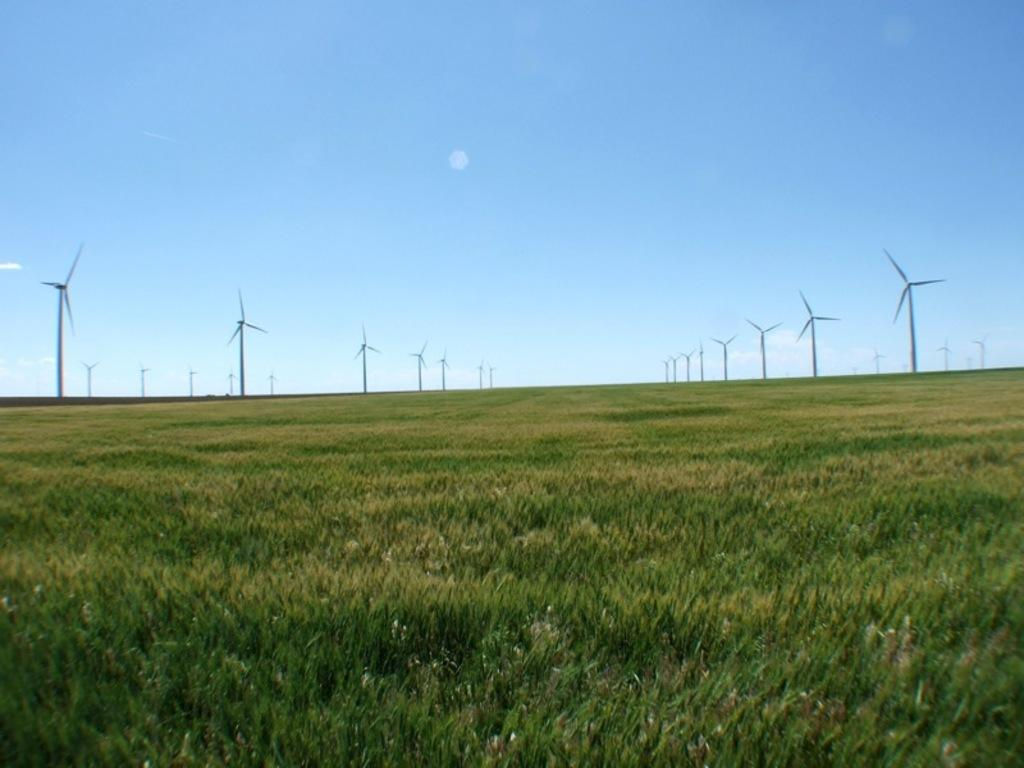What type of landscape is depicted in the image? The image features fields. What structures can be seen in the fields? There are windmills in the image. What is visible in the background of the image? The sky is visible in the background of the image. What type of transport can be seen in the image? There is no transport visible in the image; it features fields and windmills. What type of cakes are being served in the image? There are no cakes present in the image. 